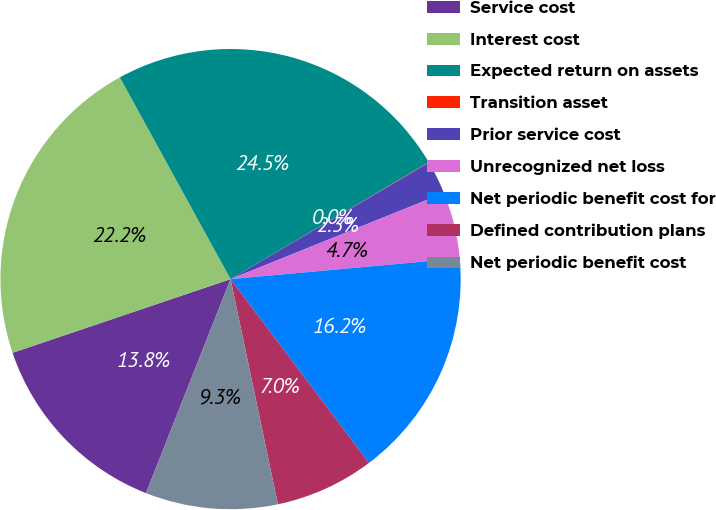Convert chart to OTSL. <chart><loc_0><loc_0><loc_500><loc_500><pie_chart><fcel>Service cost<fcel>Interest cost<fcel>Expected return on assets<fcel>Transition asset<fcel>Prior service cost<fcel>Unrecognized net loss<fcel>Net periodic benefit cost for<fcel>Defined contribution plans<fcel>Net periodic benefit cost<nl><fcel>13.82%<fcel>22.2%<fcel>24.51%<fcel>0.03%<fcel>2.35%<fcel>4.66%<fcel>16.17%<fcel>6.97%<fcel>9.29%<nl></chart> 